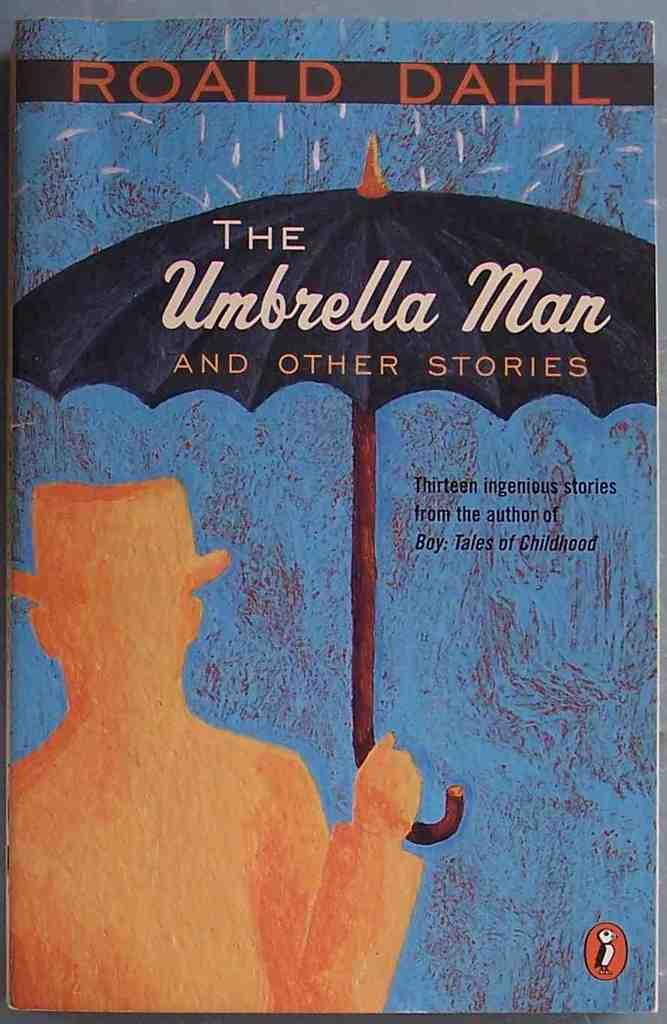<image>
Render a clear and concise summary of the photo. The book The Umbrella Man and Other Stories by Roald Dahl is shown. 